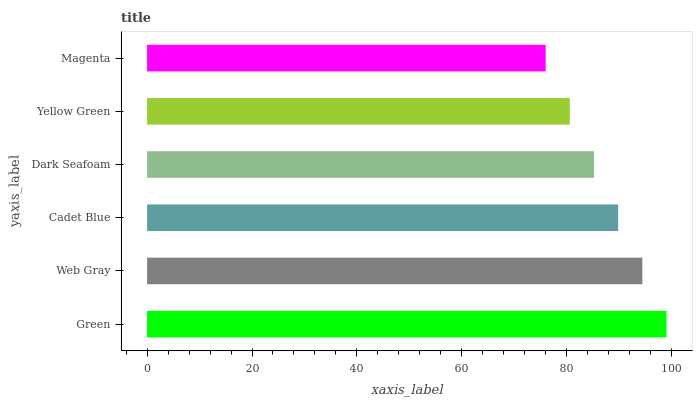Is Magenta the minimum?
Answer yes or no. Yes. Is Green the maximum?
Answer yes or no. Yes. Is Web Gray the minimum?
Answer yes or no. No. Is Web Gray the maximum?
Answer yes or no. No. Is Green greater than Web Gray?
Answer yes or no. Yes. Is Web Gray less than Green?
Answer yes or no. Yes. Is Web Gray greater than Green?
Answer yes or no. No. Is Green less than Web Gray?
Answer yes or no. No. Is Cadet Blue the high median?
Answer yes or no. Yes. Is Dark Seafoam the low median?
Answer yes or no. Yes. Is Dark Seafoam the high median?
Answer yes or no. No. Is Green the low median?
Answer yes or no. No. 